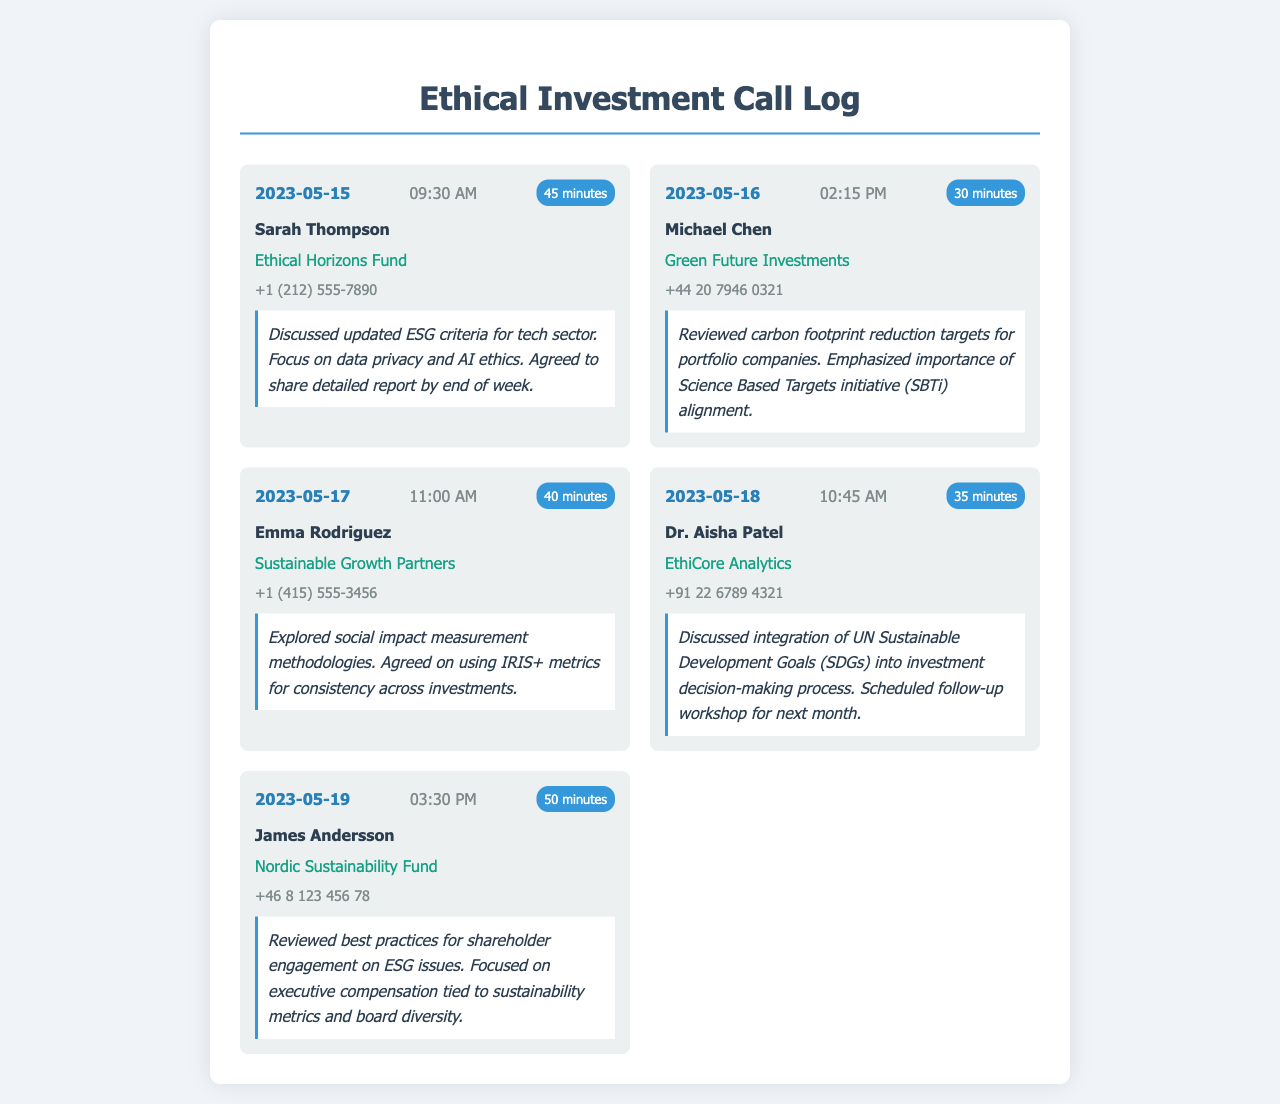What date was the call with Sarah Thompson? The document indicates that the call with Sarah Thompson took place on May 15, 2023.
Answer: May 15, 2023 How long was the call with James Andersson? According to the call log, the duration of the call with James Andersson was 50 minutes.
Answer: 50 minutes What company is Dr. Aisha Patel associated with? The document states that Dr. Aisha Patel is associated with EthiCore Analytics.
Answer: EthiCore Analytics What was discussed during the call with Emma Rodriguez? The call notes for Emma Rodriguez state that they explored social impact measurement methodologies.
Answer: social impact measurement methodologies Which initiative's alignment was emphasized in the call with Michael Chen? The call with Michael Chen emphasized the importance of Science Based Targets initiative (SBTi) alignment.
Answer: Science Based Targets initiative (SBTi) 